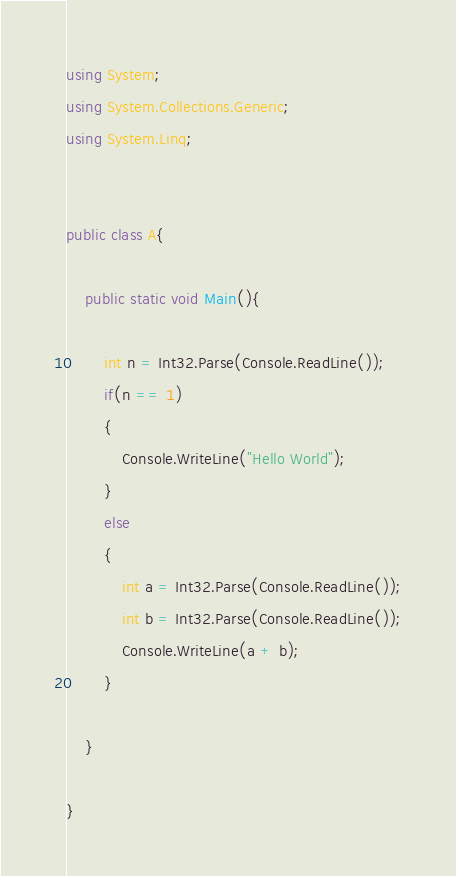<code> <loc_0><loc_0><loc_500><loc_500><_C#_>using System;
using System.Collections.Generic;
using System.Linq;


public class A{
	
	public static void Main(){
	
		int n = Int32.Parse(Console.ReadLine());
		if(n == 1)
		{
			Console.WriteLine("Hello World");			
		}
		else
		{
			int a = Int32.Parse(Console.ReadLine());
			int b = Int32.Parse(Console.ReadLine());
			Console.WriteLine(a + b);
		}		
		
	}
	
}</code> 